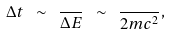<formula> <loc_0><loc_0><loc_500><loc_500>\Delta t \ \sim \ \frac { } { \Delta E } \ \sim \ \frac { } { 2 m c ^ { 2 } } ,</formula> 